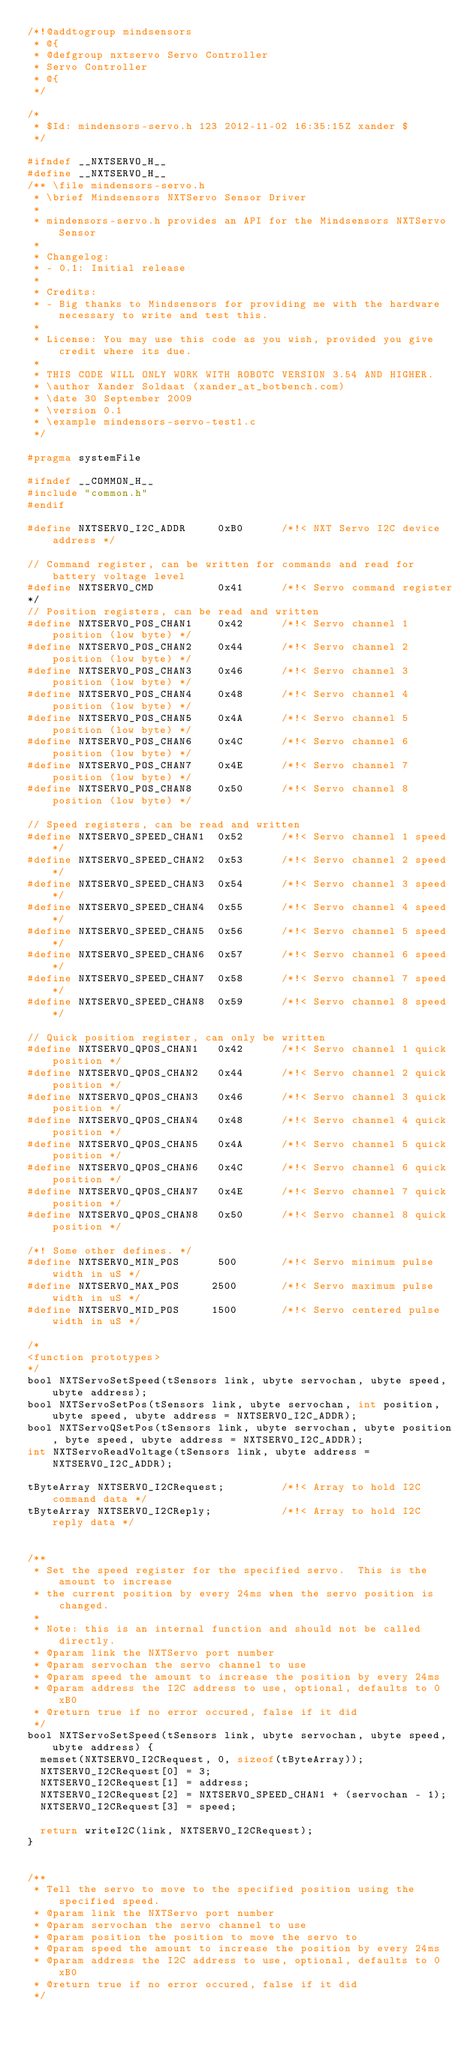<code> <loc_0><loc_0><loc_500><loc_500><_C_>/*!@addtogroup mindsensors
 * @{
 * @defgroup nxtservo Servo Controller
 * Servo Controller
 * @{
 */

/*
 * $Id: mindensors-servo.h 123 2012-11-02 16:35:15Z xander $
 */

#ifndef __NXTSERVO_H__
#define __NXTSERVO_H__
/** \file mindensors-servo.h
 * \brief Mindsensors NXTServo Sensor Driver
 *
 * mindensors-servo.h provides an API for the Mindsensors NXTServo Sensor
 *
 * Changelog:
 * - 0.1: Initial release
 *
 * Credits:
 * - Big thanks to Mindsensors for providing me with the hardware necessary to write and test this.
 *
 * License: You may use this code as you wish, provided you give credit where its due.
 *
 * THIS CODE WILL ONLY WORK WITH ROBOTC VERSION 3.54 AND HIGHER.
 * \author Xander Soldaat (xander_at_botbench.com)
 * \date 30 September 2009
 * \version 0.1
 * \example mindensors-servo-test1.c
 */

#pragma systemFile

#ifndef __COMMON_H__
#include "common.h"
#endif

#define NXTSERVO_I2C_ADDR     0xB0      /*!< NXT Servo I2C device address */

// Command register, can be written for commands and read for battery voltage level
#define NXTSERVO_CMD          0x41      /*!< Servo command register
*/
// Position registers, can be read and written
#define NXTSERVO_POS_CHAN1    0x42      /*!< Servo channel 1 position (low byte) */
#define NXTSERVO_POS_CHAN2    0x44      /*!< Servo channel 2 position (low byte) */
#define NXTSERVO_POS_CHAN3    0x46      /*!< Servo channel 3 position (low byte) */
#define NXTSERVO_POS_CHAN4    0x48      /*!< Servo channel 4 position (low byte) */
#define NXTSERVO_POS_CHAN5    0x4A      /*!< Servo channel 5 position (low byte) */
#define NXTSERVO_POS_CHAN6    0x4C      /*!< Servo channel 6 position (low byte) */
#define NXTSERVO_POS_CHAN7    0x4E      /*!< Servo channel 7 position (low byte) */
#define NXTSERVO_POS_CHAN8    0x50      /*!< Servo channel 8 position (low byte) */

// Speed registers, can be read and written
#define NXTSERVO_SPEED_CHAN1  0x52      /*!< Servo channel 1 speed */
#define NXTSERVO_SPEED_CHAN2  0x53      /*!< Servo channel 2 speed */
#define NXTSERVO_SPEED_CHAN3  0x54      /*!< Servo channel 3 speed */
#define NXTSERVO_SPEED_CHAN4  0x55      /*!< Servo channel 4 speed */
#define NXTSERVO_SPEED_CHAN5  0x56      /*!< Servo channel 5 speed */
#define NXTSERVO_SPEED_CHAN6  0x57      /*!< Servo channel 6 speed */
#define NXTSERVO_SPEED_CHAN7  0x58      /*!< Servo channel 7 speed */
#define NXTSERVO_SPEED_CHAN8  0x59      /*!< Servo channel 8 speed */

// Quick position register, can only be written
#define NXTSERVO_QPOS_CHAN1   0x42      /*!< Servo channel 1 quick position */
#define NXTSERVO_QPOS_CHAN2   0x44      /*!< Servo channel 2 quick position */
#define NXTSERVO_QPOS_CHAN3   0x46      /*!< Servo channel 3 quick position */
#define NXTSERVO_QPOS_CHAN4   0x48      /*!< Servo channel 4 quick position */
#define NXTSERVO_QPOS_CHAN5   0x4A      /*!< Servo channel 5 quick position */
#define NXTSERVO_QPOS_CHAN6   0x4C      /*!< Servo channel 6 quick position */
#define NXTSERVO_QPOS_CHAN7   0x4E      /*!< Servo channel 7 quick position */
#define NXTSERVO_QPOS_CHAN8   0x50      /*!< Servo channel 8 quick position */

/*! Some other defines. */
#define NXTSERVO_MIN_POS      500       /*!< Servo minimum pulse width in uS */
#define NXTSERVO_MAX_POS     2500       /*!< Servo maximum pulse width in uS */
#define NXTSERVO_MID_POS     1500       /*!< Servo centered pulse width in uS */

/*
<function prototypes>
*/
bool NXTServoSetSpeed(tSensors link, ubyte servochan, ubyte speed, ubyte address);
bool NXTServoSetPos(tSensors link, ubyte servochan, int position, ubyte speed, ubyte address = NXTSERVO_I2C_ADDR);
bool NXTServoQSetPos(tSensors link, ubyte servochan, ubyte position, byte speed, ubyte address = NXTSERVO_I2C_ADDR);
int NXTServoReadVoltage(tSensors link, ubyte address = NXTSERVO_I2C_ADDR);

tByteArray NXTSERVO_I2CRequest;         /*!< Array to hold I2C command data */
tByteArray NXTSERVO_I2CReply;           /*!< Array to hold I2C reply data */


/**
 * Set the speed register for the specified servo.  This is the amount to increase
 * the current position by every 24ms when the servo position is changed.
 *
 * Note: this is an internal function and should not be called directly.
 * @param link the NXTServo port number
 * @param servochan the servo channel to use
 * @param speed the amount to increase the position by every 24ms
 * @param address the I2C address to use, optional, defaults to 0xB0
 * @return true if no error occured, false if it did
 */
bool NXTServoSetSpeed(tSensors link, ubyte servochan, ubyte speed, ubyte address) {
  memset(NXTSERVO_I2CRequest, 0, sizeof(tByteArray));
  NXTSERVO_I2CRequest[0] = 3;
  NXTSERVO_I2CRequest[1] = address;
  NXTSERVO_I2CRequest[2] = NXTSERVO_SPEED_CHAN1 + (servochan - 1);
  NXTSERVO_I2CRequest[3] = speed;

  return writeI2C(link, NXTSERVO_I2CRequest);
}


/**
 * Tell the servo to move to the specified position using the specified speed.
 * @param link the NXTServo port number
 * @param servochan the servo channel to use
 * @param position the position to move the servo to
 * @param speed the amount to increase the position by every 24ms
 * @param address the I2C address to use, optional, defaults to 0xB0
 * @return true if no error occured, false if it did
 */</code> 